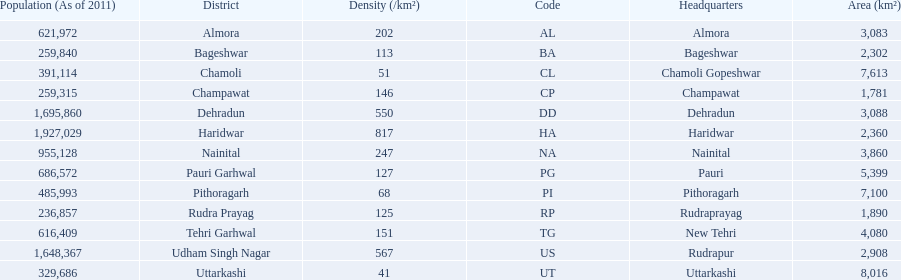What is the next most populous district after haridwar? Dehradun. 